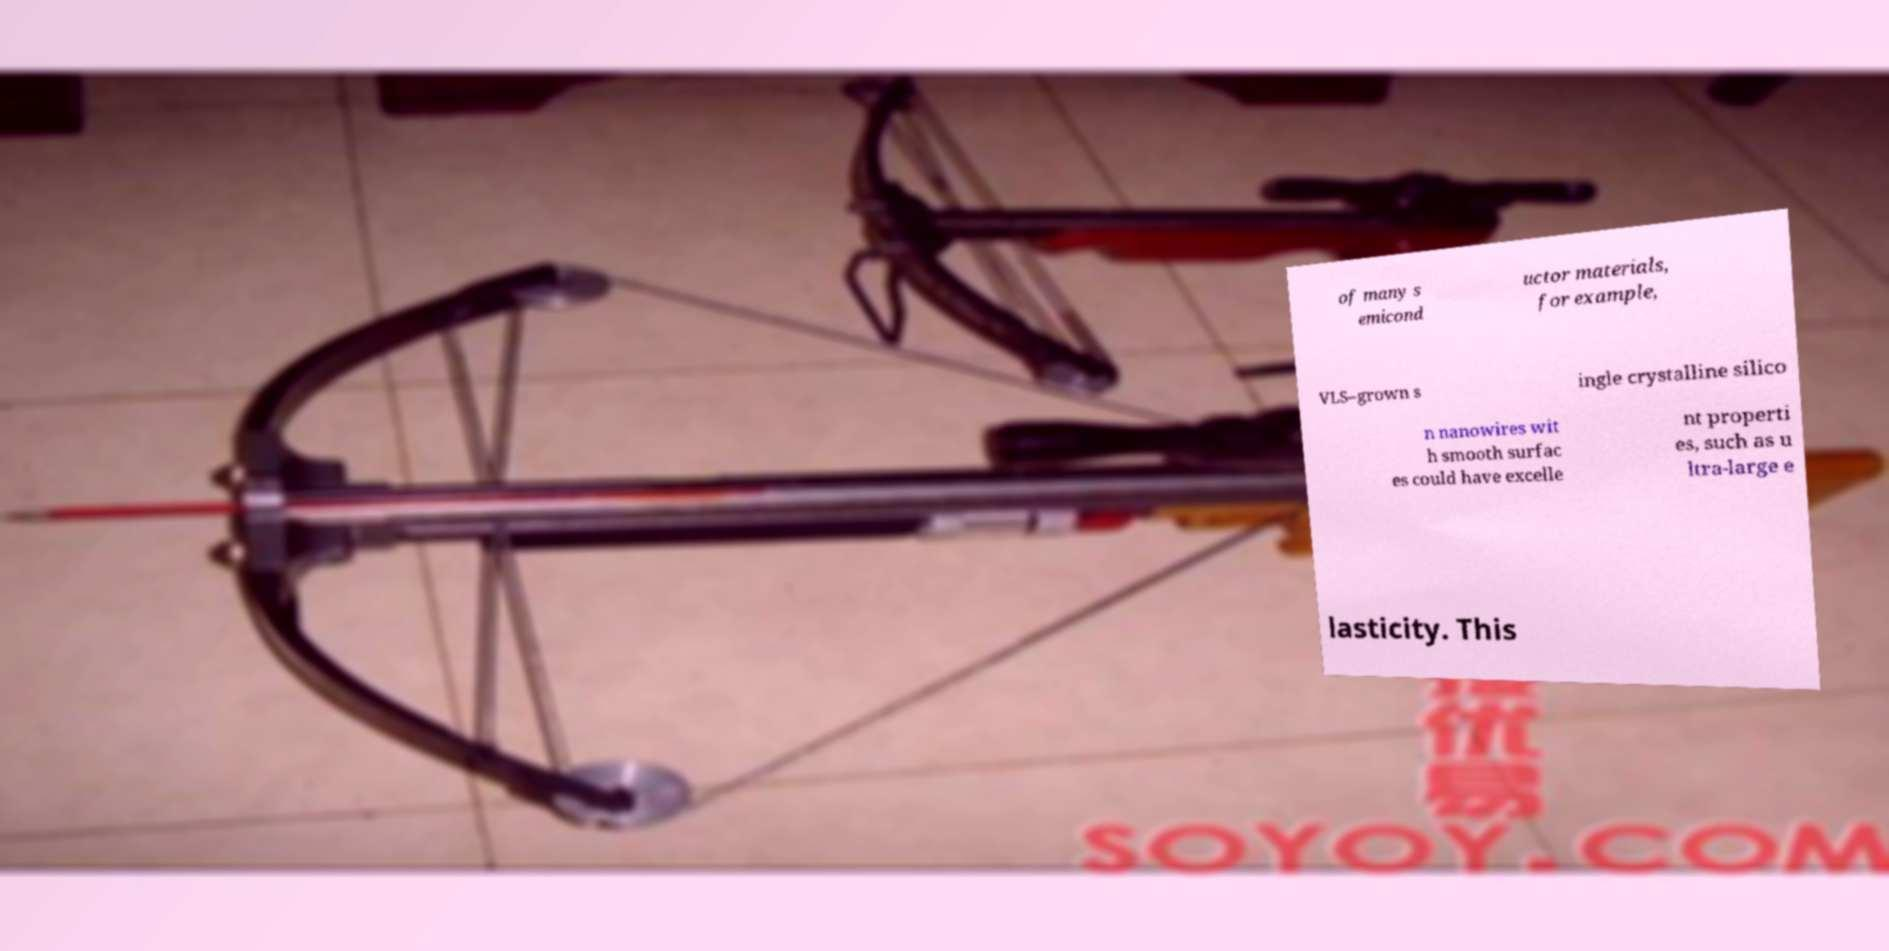Can you read and provide the text displayed in the image?This photo seems to have some interesting text. Can you extract and type it out for me? of many s emicond uctor materials, for example, VLS–grown s ingle crystalline silico n nanowires wit h smooth surfac es could have excelle nt properti es, such as u ltra-large e lasticity. This 